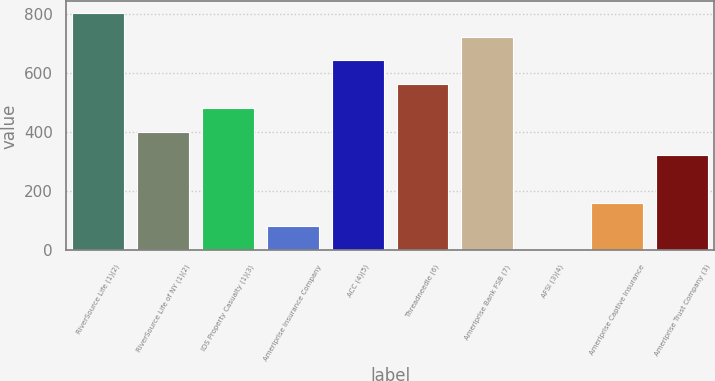Convert chart. <chart><loc_0><loc_0><loc_500><loc_500><bar_chart><fcel>RiverSource Life (1)(2)<fcel>RiverSource Life of NY (1)(2)<fcel>IDS Property Casualty (1)(3)<fcel>Ameriprise Insurance Company<fcel>ACC (4)(5)<fcel>Threadneedle (6)<fcel>Ameriprise Bank FSB (7)<fcel>AFSI (3)(4)<fcel>Ameriprise Captive Insurance<fcel>Ameriprise Trust Company (3)<nl><fcel>803<fcel>402<fcel>482.2<fcel>81.2<fcel>642.6<fcel>562.4<fcel>722.8<fcel>1<fcel>161.4<fcel>321.8<nl></chart> 